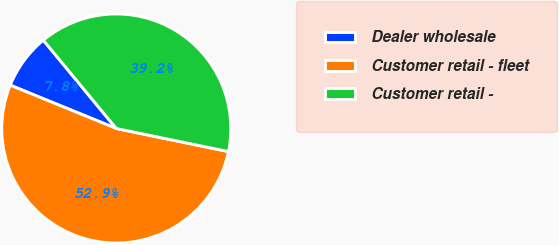<chart> <loc_0><loc_0><loc_500><loc_500><pie_chart><fcel>Dealer wholesale<fcel>Customer retail - fleet<fcel>Customer retail -<nl><fcel>7.84%<fcel>52.94%<fcel>39.22%<nl></chart> 